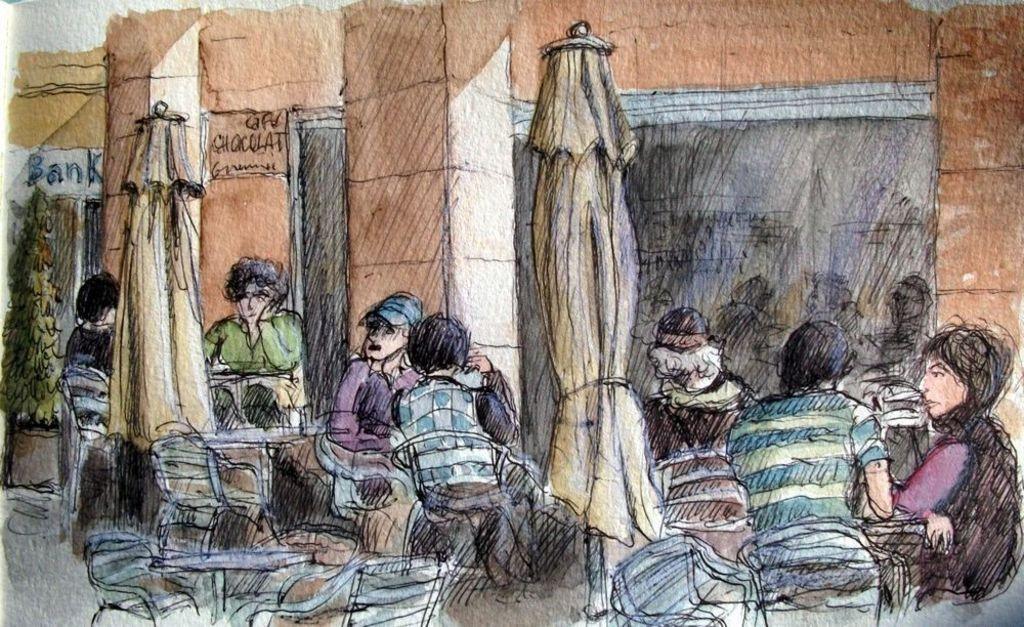Describe this image in one or two sentences. This image consists of a painting in which there are many persons along with umbrellas. In the background, there is a building and bank. The walls are in brown color. To the left, there is a plant. 